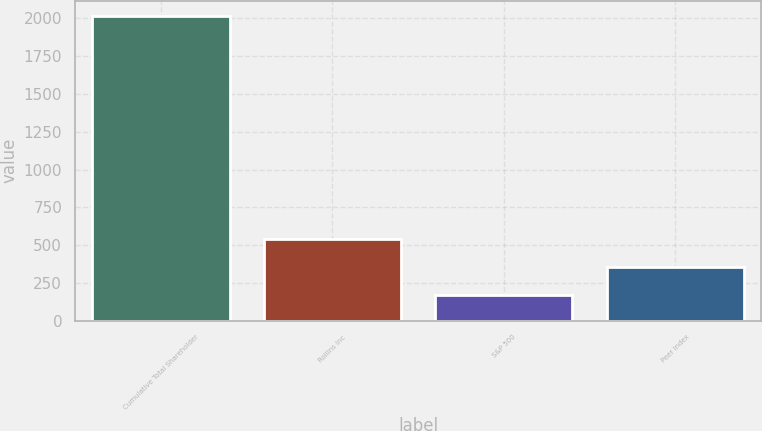Convert chart. <chart><loc_0><loc_0><loc_500><loc_500><bar_chart><fcel>Cumulative Total Shareholder<fcel>Rollins Inc<fcel>S&P 500<fcel>Peer Index<nl><fcel>2016<fcel>539.88<fcel>170.84<fcel>355.36<nl></chart> 